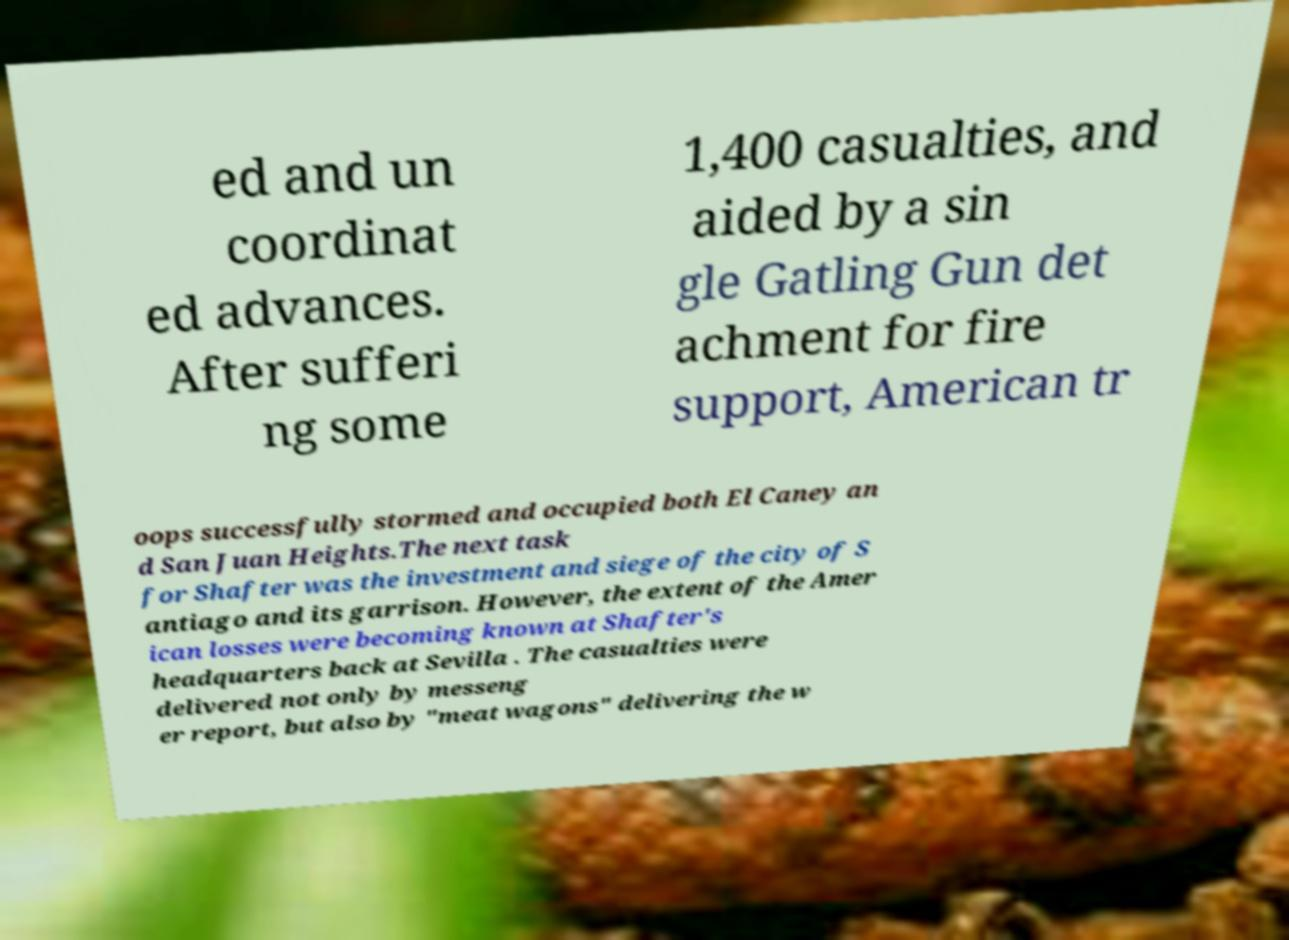Please read and relay the text visible in this image. What does it say? ed and un coordinat ed advances. After sufferi ng some 1,400 casualties, and aided by a sin gle Gatling Gun det achment for fire support, American tr oops successfully stormed and occupied both El Caney an d San Juan Heights.The next task for Shafter was the investment and siege of the city of S antiago and its garrison. However, the extent of the Amer ican losses were becoming known at Shafter's headquarters back at Sevilla . The casualties were delivered not only by messeng er report, but also by "meat wagons" delivering the w 